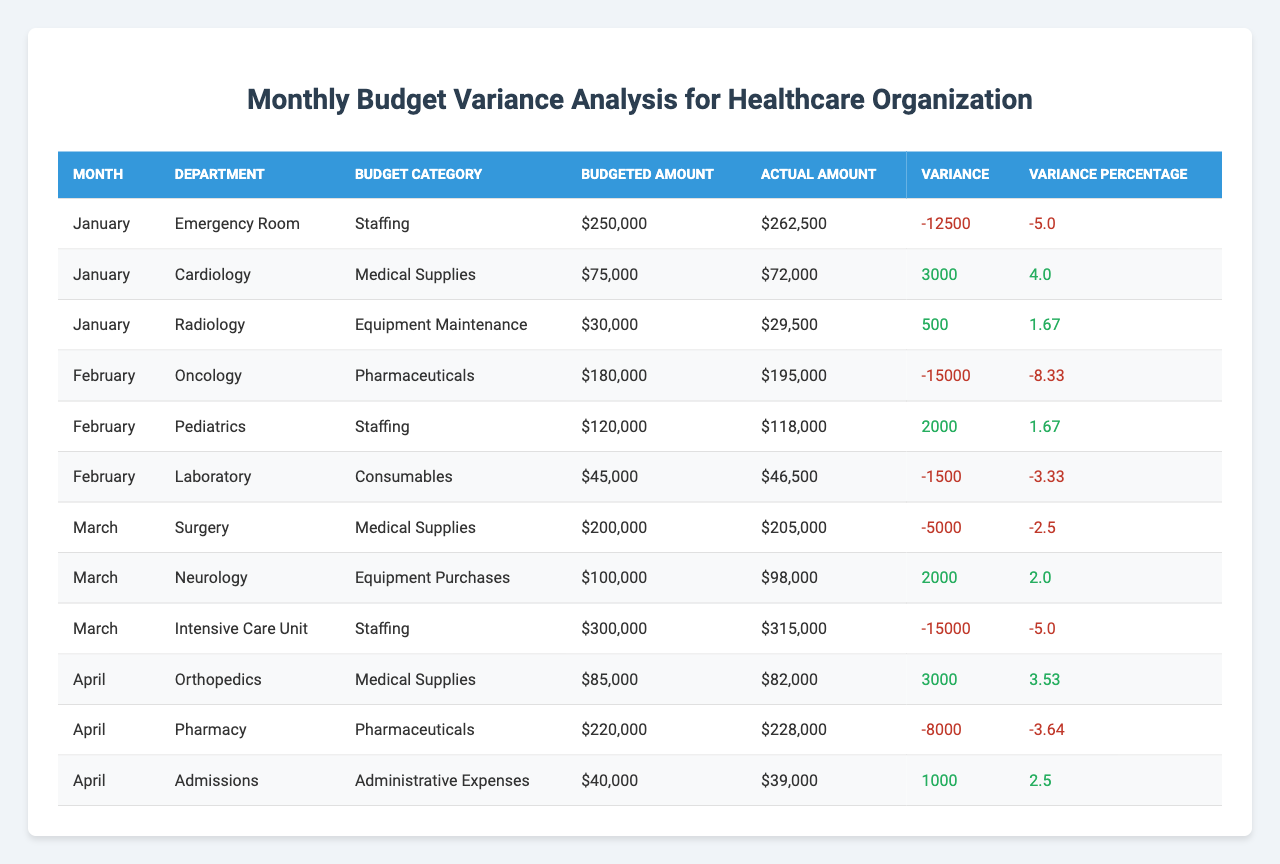What is the budgeted amount for the Emergency Room in January? The table shows the row for the Emergency Room for January, indicating the budgeted amount of $250,000.
Answer: $250,000 Which department exceeded its budget in January? In January, the Emergency Room has an actual amount of $262,500 against a budget of $250,000, resulting in a negative variance, indicating it exceeded the budget.
Answer: Emergency Room What is the variance percentage for the Pharmacy budget in April? For the Pharmacy, the table indicates a budgeted amount of $220,000 and an actual amount of $228,000. The variance is calculated as ($228,000 - $220,000) / $220,000 * 100, which equals -3.64%.
Answer: -3.64% How much was overspent in total across all departments in February? In February, the overspending amounts are: Oncology (-$15,000), Laboratory (-$1,500). Summing these gives: -15,000 + -1,500 = -16,500, indicating total overspending.
Answer: $16,500 Which department had the highest actual spending in March? The actual spending amounts in March are: Surgery ($205,000), Neurology ($98,000), and Intensive Care Unit ($315,000). The highest is $315,000 for the Intensive Care Unit.
Answer: Intensive Care Unit Is there any department with a positive variance in March? Checking the variances in March shows: Surgery (-$5,000), Neurology ($2,000), Intensive Care Unit (-$15,000). Only Neurology has a positive variance ($2,000).
Answer: Yes What were the total budgeted amounts for the departments in April? The budgeted amounts for April are: Orthopedics ($85,000), Pharmacy ($220,000), Admissions ($40,000). Adding these: 85,000 + 220,000 + 40,000 = $345,000 provides the total budgeted amount.
Answer: $345,000 What is the average variance percentage for the Emergency Room over the time period in the table? The Emergency Room has variances of -5% in January and -5% in March. To find the average, sum (-5 + -5) = -10, then divide by 2 to get -5%.
Answer: -5% Which month had the highest negative variance percentage overall? Analyzing the variance percentages: January (varied between -5% and +4%), February (varied with -8.33% for Oncology), and March (varied with -5% for Intensive Care Unit), February's -8.33% for Oncology is the highest negative variance.
Answer: February If we combined the total actual spending for all departments in January, what would that amount be? In January, the actual amounts are: Emergency Room ($262,500), Cardiology ($72,000), Radiology ($29,500). Adding these up: 262,500 + 72,000 + 29,500 = $364,000 gives the total actual spending.
Answer: $364,000 